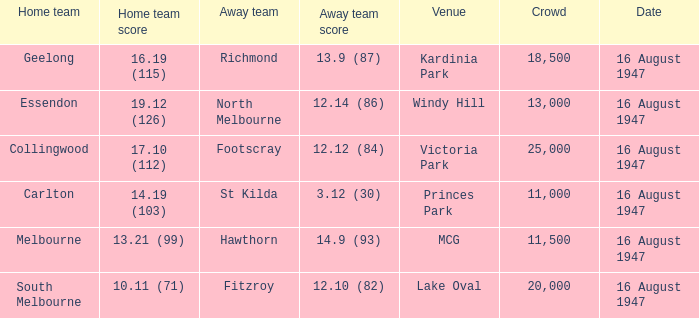What was the total size of the crowd when the away team scored 12.10 (82)? 20000.0. 